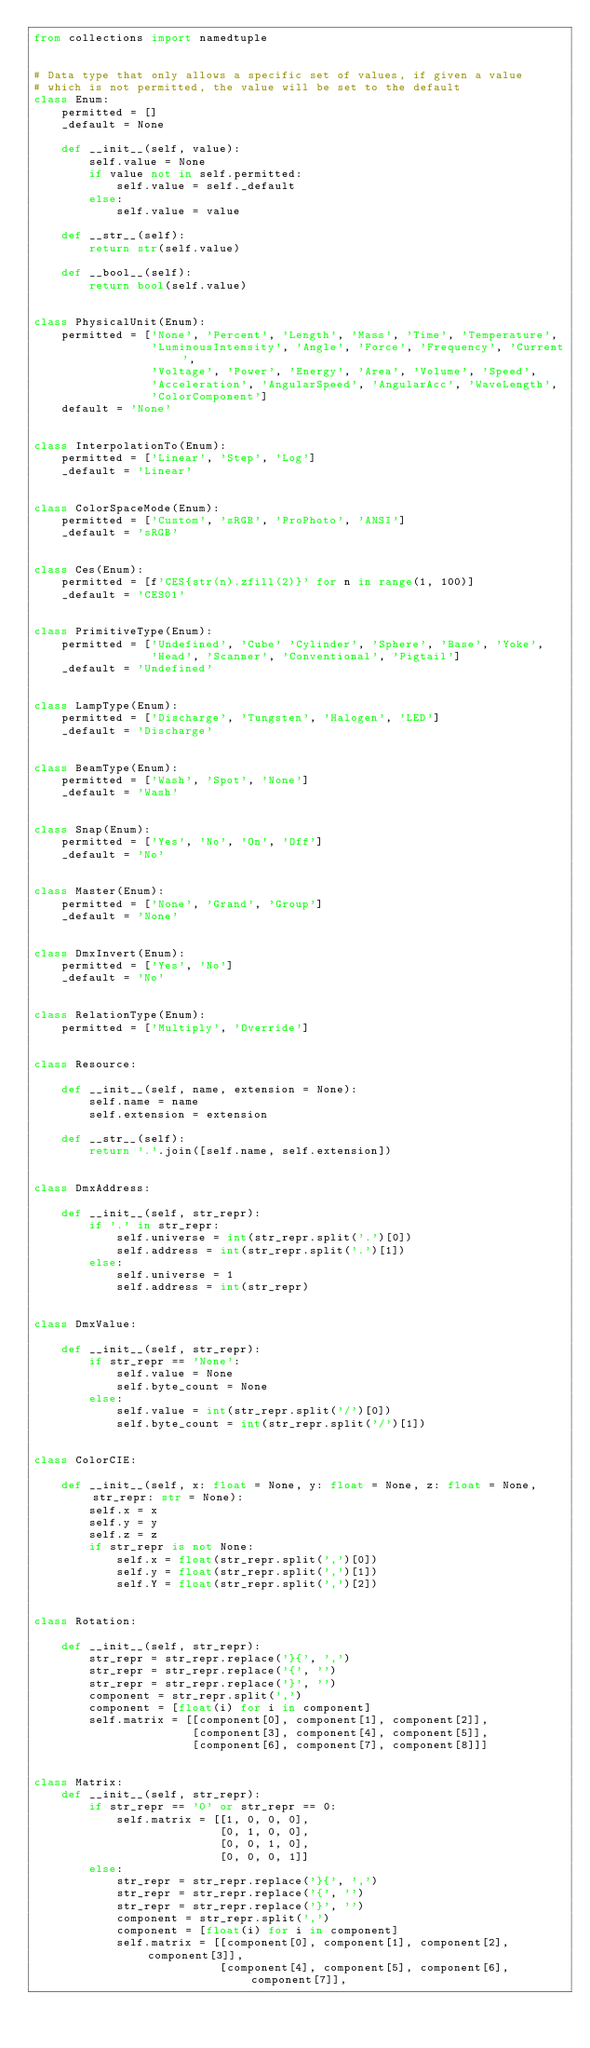Convert code to text. <code><loc_0><loc_0><loc_500><loc_500><_Python_>from collections import namedtuple


# Data type that only allows a specific set of values, if given a value
# which is not permitted, the value will be set to the default
class Enum:
    permitted = []
    _default = None

    def __init__(self, value):
        self.value = None
        if value not in self.permitted:
            self.value = self._default
        else:
            self.value = value

    def __str__(self):
        return str(self.value)

    def __bool__(self):
        return bool(self.value)


class PhysicalUnit(Enum):
    permitted = ['None', 'Percent', 'Length', 'Mass', 'Time', 'Temperature',
                 'LuminousIntensity', 'Angle', 'Force', 'Frequency', 'Current',
                 'Voltage', 'Power', 'Energy', 'Area', 'Volume', 'Speed',
                 'Acceleration', 'AngularSpeed', 'AngularAcc', 'WaveLength',
                 'ColorComponent']
    default = 'None'


class InterpolationTo(Enum):
    permitted = ['Linear', 'Step', 'Log']
    _default = 'Linear'


class ColorSpaceMode(Enum):
    permitted = ['Custom', 'sRGB', 'ProPhoto', 'ANSI']
    _default = 'sRGB'


class Ces(Enum):
    permitted = [f'CES{str(n).zfill(2)}' for n in range(1, 100)]
    _default = 'CES01'


class PrimitiveType(Enum):
    permitted = ['Undefined', 'Cube' 'Cylinder', 'Sphere', 'Base', 'Yoke',
                 'Head', 'Scanner', 'Conventional', 'Pigtail']
    _default = 'Undefined'


class LampType(Enum):
    permitted = ['Discharge', 'Tungsten', 'Halogen', 'LED']
    _default = 'Discharge'


class BeamType(Enum):
    permitted = ['Wash', 'Spot', 'None']
    _default = 'Wash'


class Snap(Enum):
    permitted = ['Yes', 'No', 'On', 'Off']
    _default = 'No'


class Master(Enum):
    permitted = ['None', 'Grand', 'Group']
    _default = 'None'


class DmxInvert(Enum):
    permitted = ['Yes', 'No']
    _default = 'No'


class RelationType(Enum):
    permitted = ['Multiply', 'Override']


class Resource:

    def __init__(self, name, extension = None):
        self.name = name
        self.extension = extension

    def __str__(self):
        return '.'.join([self.name, self.extension])


class DmxAddress:

    def __init__(self, str_repr):
        if '.' in str_repr:
            self.universe = int(str_repr.split('.')[0])
            self.address = int(str_repr.split('.')[1])
        else:
            self.universe = 1
            self.address = int(str_repr)


class DmxValue:

    def __init__(self, str_repr):
        if str_repr == 'None':
            self.value = None
            self.byte_count = None
        else:
            self.value = int(str_repr.split('/')[0])
            self.byte_count = int(str_repr.split('/')[1])


class ColorCIE:

    def __init__(self, x: float = None, y: float = None, z: float = None, str_repr: str = None):
        self.x = x
        self.y = y
        self.z = z
        if str_repr is not None:
            self.x = float(str_repr.split(',')[0])
            self.y = float(str_repr.split(',')[1])
            self.Y = float(str_repr.split(',')[2])


class Rotation:

    def __init__(self, str_repr):
        str_repr = str_repr.replace('}{', ',')
        str_repr = str_repr.replace('{', '')
        str_repr = str_repr.replace('}', '')
        component = str_repr.split(',')
        component = [float(i) for i in component]
        self.matrix = [[component[0], component[1], component[2]],
                       [component[3], component[4], component[5]],
                       [component[6], component[7], component[8]]]


class Matrix:
    def __init__(self, str_repr):
        if str_repr == '0' or str_repr == 0:
            self.matrix = [[1, 0, 0, 0],
                           [0, 1, 0, 0],
                           [0, 0, 1, 0],
                           [0, 0, 0, 1]]
        else:
            str_repr = str_repr.replace('}{', ',')
            str_repr = str_repr.replace('{', '')
            str_repr = str_repr.replace('}', '')
            component = str_repr.split(',')
            component = [float(i) for i in component]
            self.matrix = [[component[0], component[1], component[2], component[3]],
                           [component[4], component[5], component[6], component[7]],</code> 